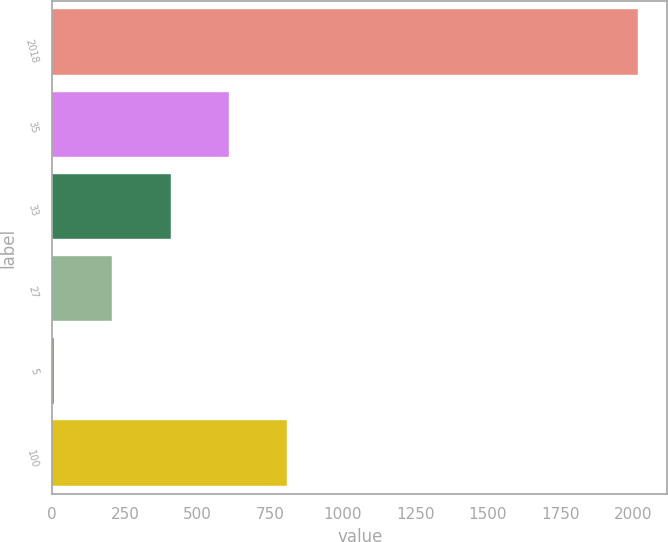Convert chart. <chart><loc_0><loc_0><loc_500><loc_500><bar_chart><fcel>2018<fcel>35<fcel>33<fcel>27<fcel>5<fcel>100<nl><fcel>2017<fcel>608.6<fcel>407.4<fcel>206.2<fcel>5<fcel>809.8<nl></chart> 